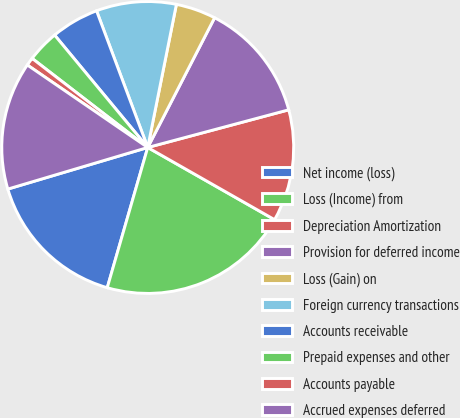<chart> <loc_0><loc_0><loc_500><loc_500><pie_chart><fcel>Net income (loss)<fcel>Loss (Income) from<fcel>Depreciation Amortization<fcel>Provision for deferred income<fcel>Loss (Gain) on<fcel>Foreign currency transactions<fcel>Accounts receivable<fcel>Prepaid expenses and other<fcel>Accounts payable<fcel>Accrued expenses deferred<nl><fcel>15.93%<fcel>21.24%<fcel>12.39%<fcel>13.27%<fcel>4.43%<fcel>8.85%<fcel>5.31%<fcel>3.54%<fcel>0.89%<fcel>14.16%<nl></chart> 